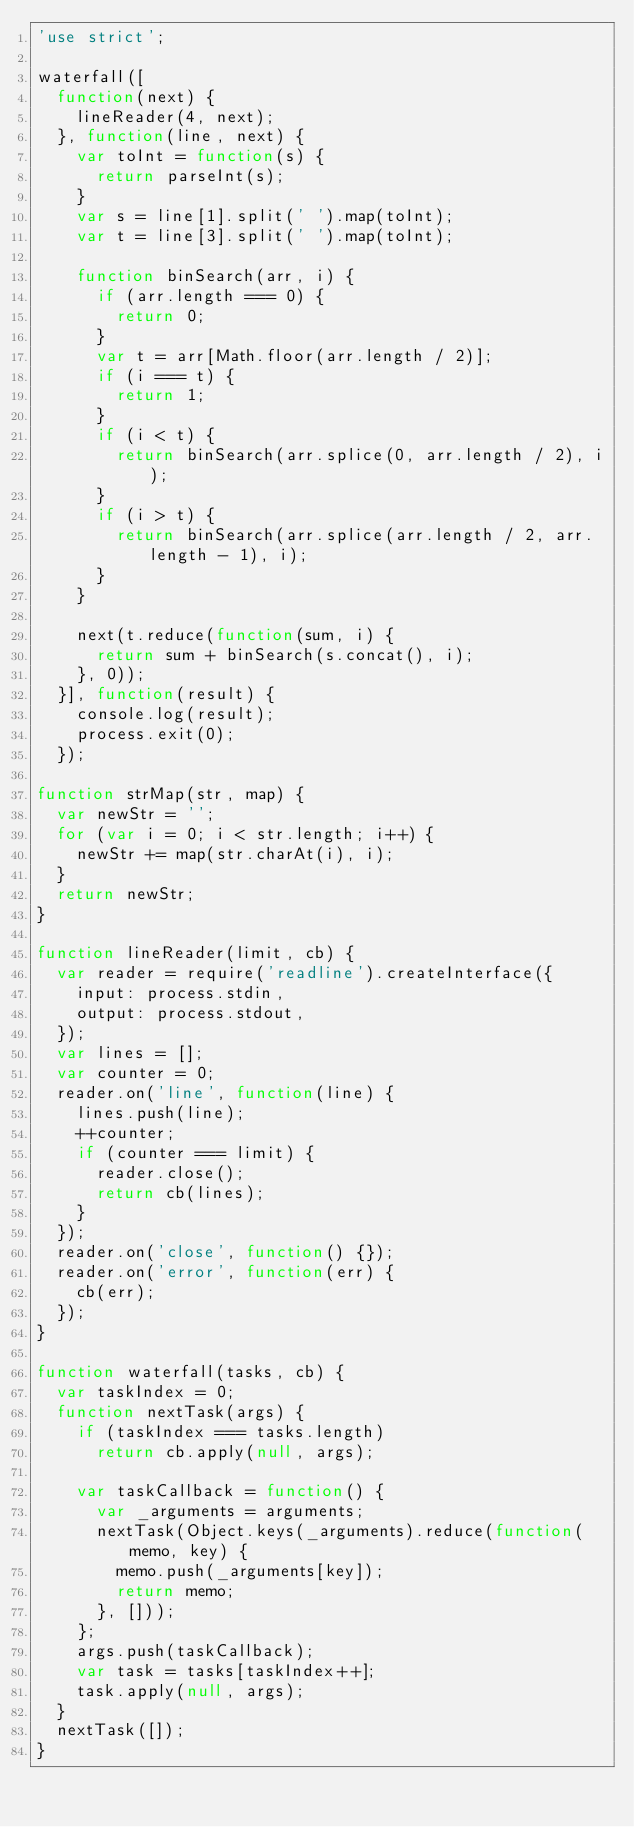Convert code to text. <code><loc_0><loc_0><loc_500><loc_500><_JavaScript_>'use strict';

waterfall([
  function(next) {
    lineReader(4, next);
  }, function(line, next) {
    var toInt = function(s) {
      return parseInt(s);
    }
    var s = line[1].split(' ').map(toInt);
    var t = line[3].split(' ').map(toInt);

    function binSearch(arr, i) {
      if (arr.length === 0) {
        return 0;
      }
      var t = arr[Math.floor(arr.length / 2)];
      if (i === t) {
        return 1;
      }
      if (i < t) {
        return binSearch(arr.splice(0, arr.length / 2), i);
      }
      if (i > t) {
        return binSearch(arr.splice(arr.length / 2, arr.length - 1), i);
      }
    }

    next(t.reduce(function(sum, i) {
      return sum + binSearch(s.concat(), i);
    }, 0));
  }], function(result) {
    console.log(result);
    process.exit(0);
  });

function strMap(str, map) {
  var newStr = '';
  for (var i = 0; i < str.length; i++) {
    newStr += map(str.charAt(i), i);
  }
  return newStr;
}

function lineReader(limit, cb) {
  var reader = require('readline').createInterface({
    input: process.stdin,
    output: process.stdout,
  });
  var lines = [];
  var counter = 0;
  reader.on('line', function(line) {
    lines.push(line);
    ++counter;
    if (counter === limit) {
      reader.close();
      return cb(lines);
    }
  });
  reader.on('close', function() {});
  reader.on('error', function(err) {
    cb(err);
  });
}

function waterfall(tasks, cb) {
  var taskIndex = 0;
  function nextTask(args) {
    if (taskIndex === tasks.length)
      return cb.apply(null, args);

    var taskCallback = function() {
      var _arguments = arguments;
      nextTask(Object.keys(_arguments).reduce(function(memo, key) {
        memo.push(_arguments[key]);
        return memo;
      }, []));
    };
    args.push(taskCallback);
    var task = tasks[taskIndex++];
    task.apply(null, args);
  }
  nextTask([]);
}</code> 